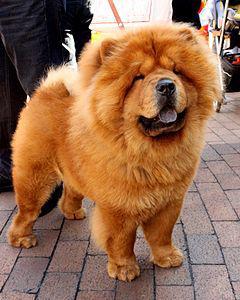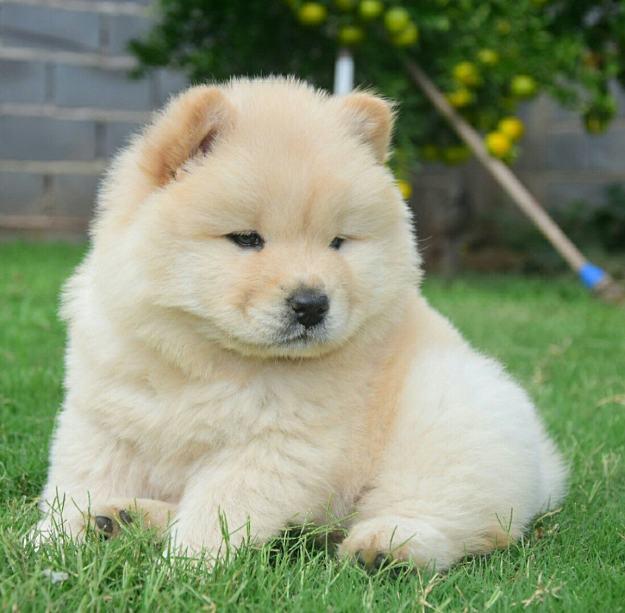The first image is the image on the left, the second image is the image on the right. Given the left and right images, does the statement "At least three dogs are shown, with only one in a grassy area." hold true? Answer yes or no. No. The first image is the image on the left, the second image is the image on the right. Examine the images to the left and right. Is the description "There are two dogs shown in total." accurate? Answer yes or no. Yes. 